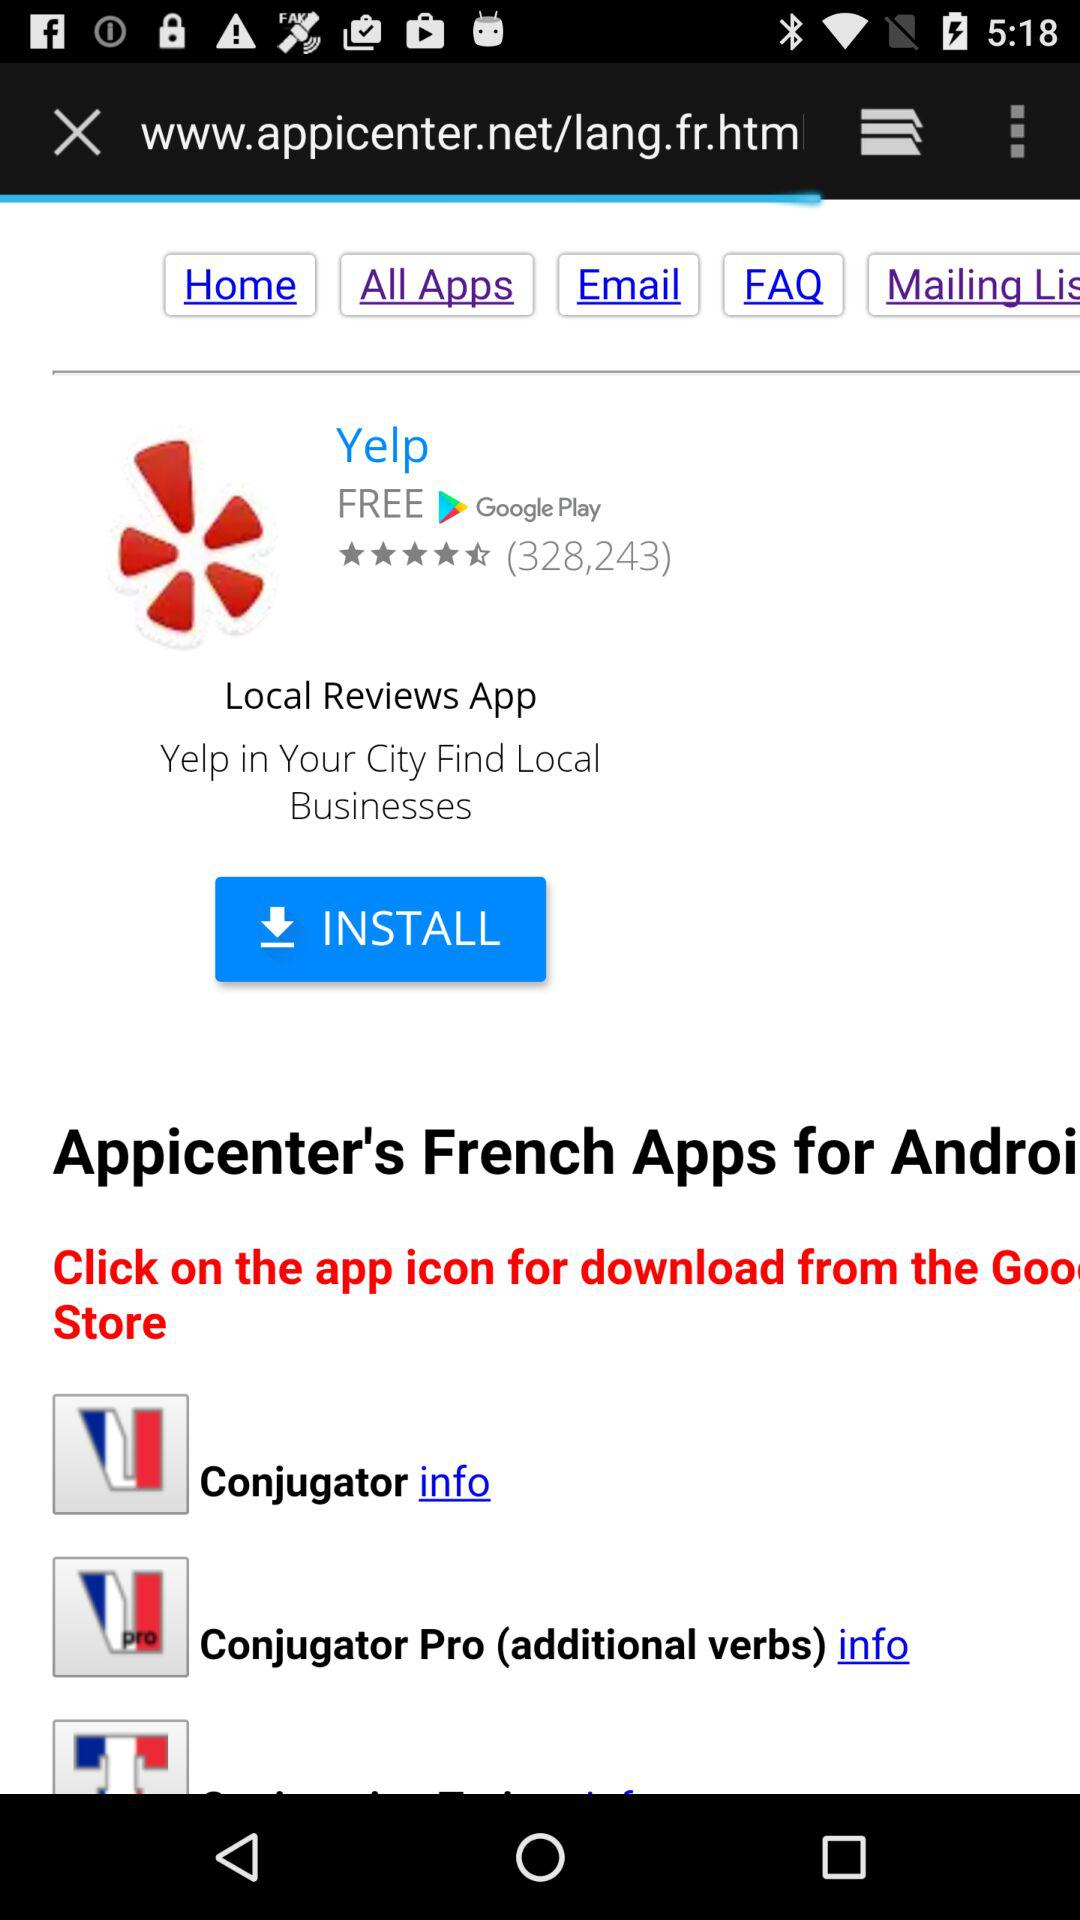What is the name of the application? The name of the application is "Yelp". 